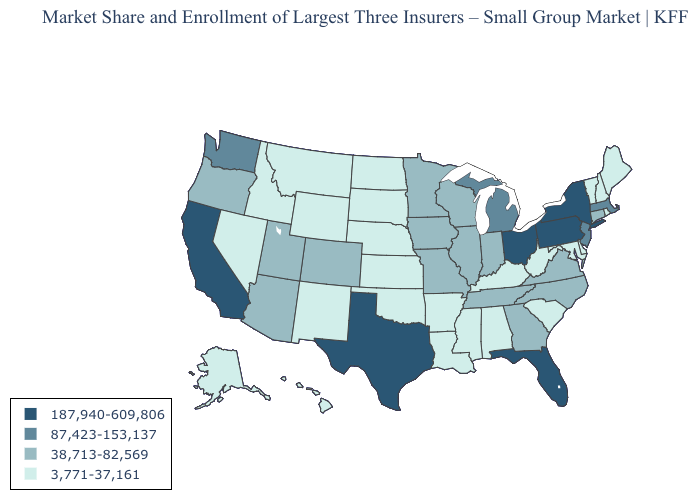What is the highest value in the Northeast ?
Concise answer only. 187,940-609,806. Name the states that have a value in the range 87,423-153,137?
Short answer required. Massachusetts, Michigan, New Jersey, Washington. Name the states that have a value in the range 3,771-37,161?
Give a very brief answer. Alabama, Alaska, Arkansas, Delaware, Hawaii, Idaho, Kansas, Kentucky, Louisiana, Maine, Maryland, Mississippi, Montana, Nebraska, Nevada, New Hampshire, New Mexico, North Dakota, Oklahoma, Rhode Island, South Carolina, South Dakota, Vermont, West Virginia, Wyoming. Does Texas have the highest value in the USA?
Short answer required. Yes. Name the states that have a value in the range 3,771-37,161?
Short answer required. Alabama, Alaska, Arkansas, Delaware, Hawaii, Idaho, Kansas, Kentucky, Louisiana, Maine, Maryland, Mississippi, Montana, Nebraska, Nevada, New Hampshire, New Mexico, North Dakota, Oklahoma, Rhode Island, South Carolina, South Dakota, Vermont, West Virginia, Wyoming. Which states have the lowest value in the Northeast?
Be succinct. Maine, New Hampshire, Rhode Island, Vermont. Name the states that have a value in the range 3,771-37,161?
Write a very short answer. Alabama, Alaska, Arkansas, Delaware, Hawaii, Idaho, Kansas, Kentucky, Louisiana, Maine, Maryland, Mississippi, Montana, Nebraska, Nevada, New Hampshire, New Mexico, North Dakota, Oklahoma, Rhode Island, South Carolina, South Dakota, Vermont, West Virginia, Wyoming. Does Louisiana have the lowest value in the USA?
Concise answer only. Yes. What is the value of West Virginia?
Answer briefly. 3,771-37,161. What is the value of Illinois?
Give a very brief answer. 38,713-82,569. Name the states that have a value in the range 87,423-153,137?
Short answer required. Massachusetts, Michigan, New Jersey, Washington. Which states have the highest value in the USA?
Concise answer only. California, Florida, New York, Ohio, Pennsylvania, Texas. What is the value of Arizona?
Short answer required. 38,713-82,569. Does Oklahoma have a higher value than North Carolina?
Short answer required. No. Name the states that have a value in the range 187,940-609,806?
Short answer required. California, Florida, New York, Ohio, Pennsylvania, Texas. 